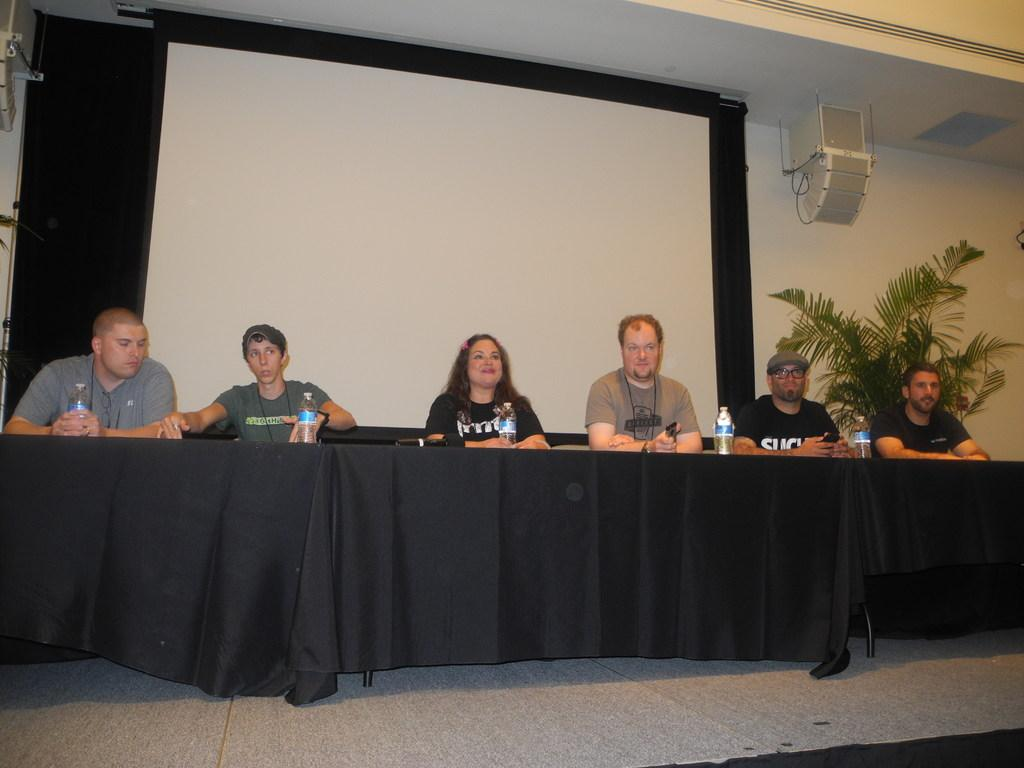What is the main subject of the image? The main subject of the image is several people sitting in front of a black table. What can be seen in the background of the image? The background of the image contains a white projector. Are there any plants or vegetation visible in the image? Yes, there is a small tree to the right of the image. What type of books can be seen on the train in the image? There is no train present in the image, so it is not possible to determine what books might be on a train. 